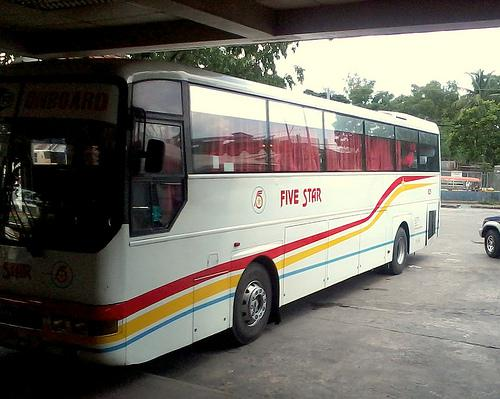Question: what color are the hubcaps?
Choices:
A. Red.
B. Blue.
C. Black.
D. Silver.
Answer with the letter. Answer: D Question: what color are the curtains?
Choices:
A. Red.
B. Brown.
C. White.
D. Blue.
Answer with the letter. Answer: A Question: where does it say FIVE STAR?
Choices:
A. On the hotel.
B. On the side of the bus.
C. On the cafe window.
D. On the menu.
Answer with the letter. Answer: B Question: who would drive the large vehicle?
Choices:
A. A bus driver.
B. A pilot.
C. A skateboarder.
D. A taxi cab driver.
Answer with the letter. Answer: A Question: how many wheels can be seen in the photo?
Choices:
A. Four.
B. Two.
C. Three.
D. One.
Answer with the letter. Answer: A Question: what color is the sky?
Choices:
A. Blue.
B. Grey.
C. White.
D. Black.
Answer with the letter. Answer: C Question: what grows in the background?
Choices:
A. Vines.
B. Trees.
C. Leaves.
D. Plants.
Answer with the letter. Answer: B Question: how many different colored stripes are on the bus?
Choices:
A. Three.
B. Two.
C. None.
D. One.
Answer with the letter. Answer: A 